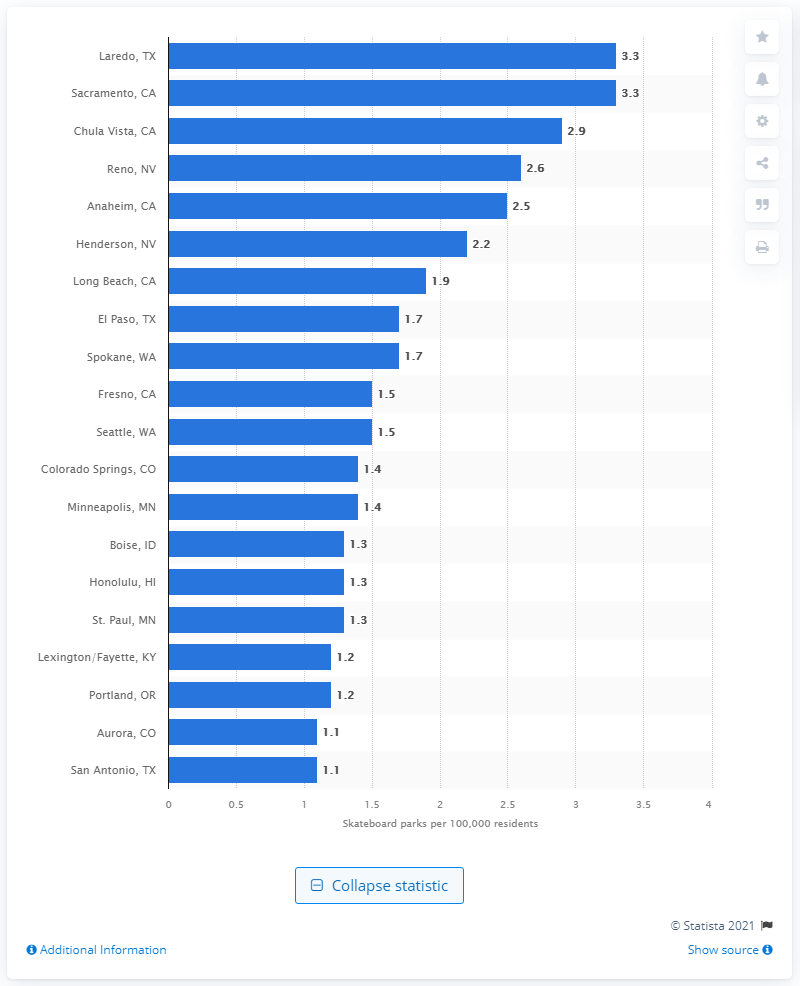Outline some significant characteristics in this image. There were 3.3 skateboard parks in Laredo, Texas in 2020. 